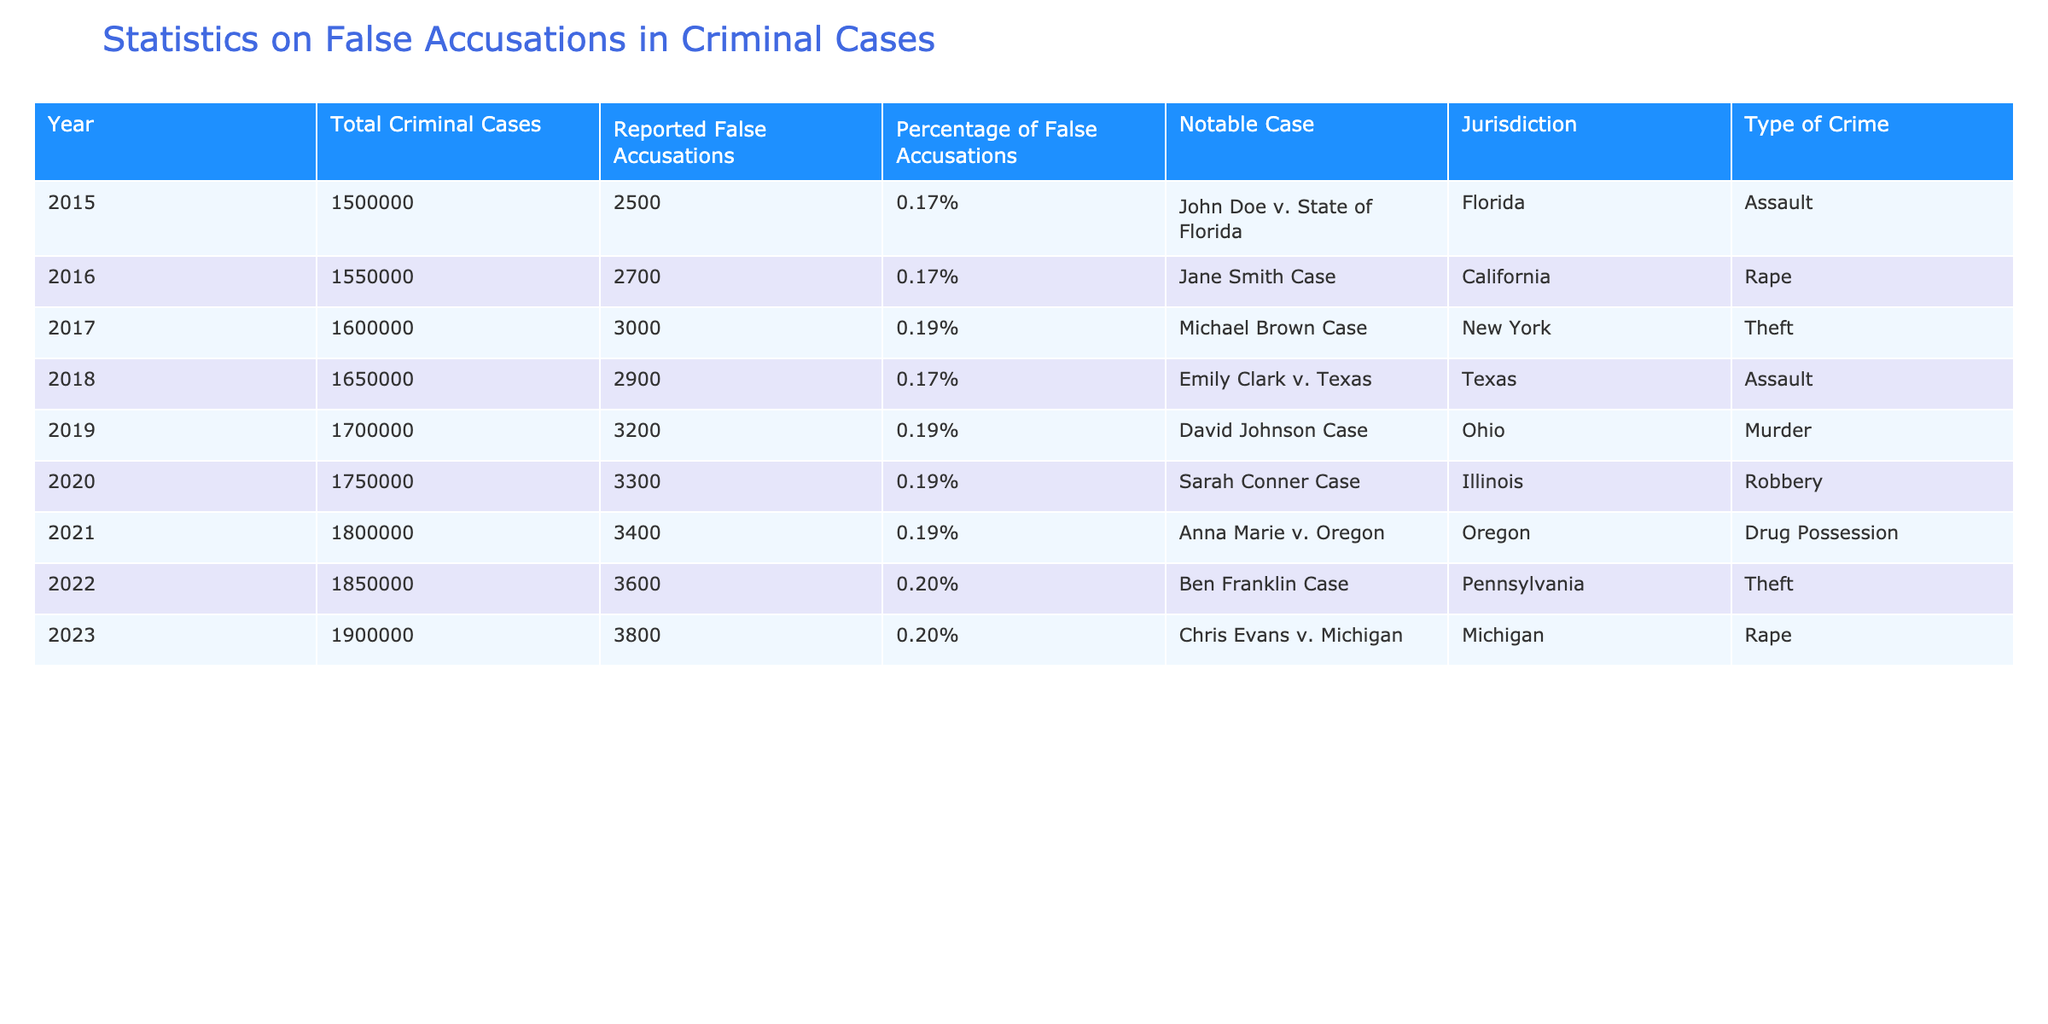What was the total number of criminal cases in 2022? Looking at the column titled "Total Criminal Cases" for the year 2022, the value listed is 1,850,000.
Answer: 1,850,000 How many reported false accusations were there in 2015? Referring to the "Reported False Accusations" column for the year 2015, the number is 2,500.
Answer: 2,500 What is the percentage of false accusations in 2023? In the column "Percentage of False Accusations" for the year 2023, the percentage is listed as 0.20%.
Answer: 0.20% Which notable case refers to a rape accusation? Looking at the "Notable Case" column, the cases listed for rape are the "Jane Smith Case" in 2016 and "Chris Evans v. Michigan" in 2023.
Answer: Jane Smith Case; Chris Evans v. Michigan What was the difference in the number of reported false accusations between 2019 and 2020? The reported false accusations for 2019 is 3,200 and for 2020 is 3,300. The difference is 3,300 - 3,200 = 100.
Answer: 100 What is the average number of reported false accusations from 2015 to 2023? The reported false accusations from 2015 to 2023 are: 2,500, 2,700, 3,000, 2,900, 3,200, 3,300, 3,400, 3,600, and 3,800. Adding these gives a total of 24,600. Then dividing by 9 (the number of years) results in an average of 2,733.33, which rounds to 2,733.
Answer: 2,733 In which year was the highest percentage of false accusations reported? By reviewing the "Percentage of False Accusations," the highest percentage is 0.20% noted for the years 2022 and 2023.
Answer: 2022 and 2023 Was there a notable case in 2021 related to drug possession? Checking for notable cases in 2021, there is indeed the "Anna Marie v. Oregon" case related to drug possession.
Answer: Yes What is the trend of false accusations from 2015 to 2023? Analyzing the reported false accusations over these years shows a consistent increase from 2,500 in 2015 to 3,800 in 2023. This indicates a rising trend.
Answer: Rising trend Which jurisdiction had the highest total number of criminal cases in this data? By examining the "Total Criminal Cases" column, 2023 shows the highest total at 1,900,000, which is in Michigan.
Answer: Michigan 